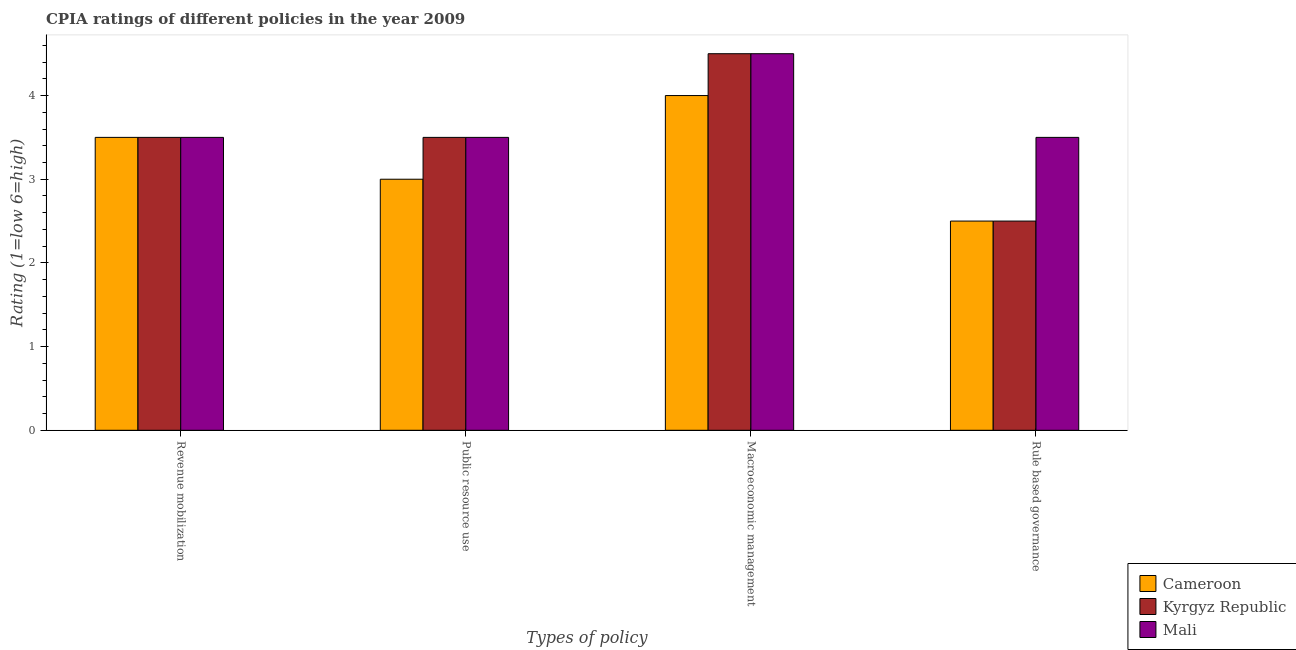How many different coloured bars are there?
Ensure brevity in your answer.  3. How many groups of bars are there?
Provide a short and direct response. 4. Are the number of bars on each tick of the X-axis equal?
Your answer should be compact. Yes. How many bars are there on the 4th tick from the right?
Ensure brevity in your answer.  3. What is the label of the 1st group of bars from the left?
Offer a very short reply. Revenue mobilization. Across all countries, what is the maximum cpia rating of public resource use?
Make the answer very short. 3.5. In which country was the cpia rating of revenue mobilization maximum?
Give a very brief answer. Cameroon. In which country was the cpia rating of revenue mobilization minimum?
Provide a short and direct response. Cameroon. What is the average cpia rating of macroeconomic management per country?
Offer a terse response. 4.33. In how many countries, is the cpia rating of public resource use greater than 3 ?
Keep it short and to the point. 2. What is the ratio of the cpia rating of public resource use in Mali to that in Kyrgyz Republic?
Make the answer very short. 1. What is the difference between the highest and the second highest cpia rating of revenue mobilization?
Your answer should be very brief. 0. What does the 1st bar from the left in Public resource use represents?
Keep it short and to the point. Cameroon. What does the 2nd bar from the right in Macroeconomic management represents?
Provide a short and direct response. Kyrgyz Republic. Is it the case that in every country, the sum of the cpia rating of revenue mobilization and cpia rating of public resource use is greater than the cpia rating of macroeconomic management?
Provide a succinct answer. Yes. Are all the bars in the graph horizontal?
Your response must be concise. No. How many countries are there in the graph?
Ensure brevity in your answer.  3. What is the difference between two consecutive major ticks on the Y-axis?
Provide a succinct answer. 1. Does the graph contain any zero values?
Offer a terse response. No. Does the graph contain grids?
Your response must be concise. No. Where does the legend appear in the graph?
Give a very brief answer. Bottom right. What is the title of the graph?
Your response must be concise. CPIA ratings of different policies in the year 2009. What is the label or title of the X-axis?
Provide a succinct answer. Types of policy. What is the Rating (1=low 6=high) in Cameroon in Revenue mobilization?
Provide a succinct answer. 3.5. What is the Rating (1=low 6=high) in Kyrgyz Republic in Revenue mobilization?
Your response must be concise. 3.5. What is the Rating (1=low 6=high) of Mali in Revenue mobilization?
Keep it short and to the point. 3.5. What is the Rating (1=low 6=high) of Cameroon in Public resource use?
Offer a very short reply. 3. What is the Rating (1=low 6=high) of Kyrgyz Republic in Public resource use?
Offer a very short reply. 3.5. What is the Rating (1=low 6=high) in Cameroon in Macroeconomic management?
Make the answer very short. 4. What is the Rating (1=low 6=high) in Kyrgyz Republic in Rule based governance?
Your answer should be compact. 2.5. What is the Rating (1=low 6=high) of Mali in Rule based governance?
Keep it short and to the point. 3.5. Across all Types of policy, what is the maximum Rating (1=low 6=high) in Cameroon?
Keep it short and to the point. 4. Across all Types of policy, what is the maximum Rating (1=low 6=high) in Kyrgyz Republic?
Provide a succinct answer. 4.5. Across all Types of policy, what is the minimum Rating (1=low 6=high) in Kyrgyz Republic?
Your response must be concise. 2.5. Across all Types of policy, what is the minimum Rating (1=low 6=high) in Mali?
Make the answer very short. 3.5. What is the total Rating (1=low 6=high) in Kyrgyz Republic in the graph?
Give a very brief answer. 14. What is the difference between the Rating (1=low 6=high) in Kyrgyz Republic in Revenue mobilization and that in Public resource use?
Keep it short and to the point. 0. What is the difference between the Rating (1=low 6=high) in Kyrgyz Republic in Revenue mobilization and that in Macroeconomic management?
Offer a very short reply. -1. What is the difference between the Rating (1=low 6=high) in Cameroon in Public resource use and that in Macroeconomic management?
Your answer should be compact. -1. What is the difference between the Rating (1=low 6=high) in Kyrgyz Republic in Public resource use and that in Macroeconomic management?
Offer a very short reply. -1. What is the difference between the Rating (1=low 6=high) of Mali in Public resource use and that in Macroeconomic management?
Your answer should be compact. -1. What is the difference between the Rating (1=low 6=high) in Cameroon in Public resource use and that in Rule based governance?
Provide a succinct answer. 0.5. What is the difference between the Rating (1=low 6=high) of Kyrgyz Republic in Public resource use and that in Rule based governance?
Provide a short and direct response. 1. What is the difference between the Rating (1=low 6=high) in Mali in Public resource use and that in Rule based governance?
Keep it short and to the point. 0. What is the difference between the Rating (1=low 6=high) of Kyrgyz Republic in Macroeconomic management and that in Rule based governance?
Provide a short and direct response. 2. What is the difference between the Rating (1=low 6=high) of Mali in Macroeconomic management and that in Rule based governance?
Give a very brief answer. 1. What is the difference between the Rating (1=low 6=high) in Cameroon in Revenue mobilization and the Rating (1=low 6=high) in Kyrgyz Republic in Public resource use?
Offer a terse response. 0. What is the difference between the Rating (1=low 6=high) in Cameroon in Revenue mobilization and the Rating (1=low 6=high) in Mali in Public resource use?
Offer a terse response. 0. What is the difference between the Rating (1=low 6=high) in Cameroon in Revenue mobilization and the Rating (1=low 6=high) in Mali in Macroeconomic management?
Provide a succinct answer. -1. What is the difference between the Rating (1=low 6=high) in Kyrgyz Republic in Revenue mobilization and the Rating (1=low 6=high) in Mali in Macroeconomic management?
Ensure brevity in your answer.  -1. What is the difference between the Rating (1=low 6=high) of Cameroon in Revenue mobilization and the Rating (1=low 6=high) of Kyrgyz Republic in Rule based governance?
Keep it short and to the point. 1. What is the difference between the Rating (1=low 6=high) of Kyrgyz Republic in Revenue mobilization and the Rating (1=low 6=high) of Mali in Rule based governance?
Your answer should be very brief. 0. What is the difference between the Rating (1=low 6=high) of Cameroon in Public resource use and the Rating (1=low 6=high) of Mali in Macroeconomic management?
Make the answer very short. -1.5. What is the difference between the Rating (1=low 6=high) of Cameroon in Macroeconomic management and the Rating (1=low 6=high) of Kyrgyz Republic in Rule based governance?
Keep it short and to the point. 1.5. What is the average Rating (1=low 6=high) in Cameroon per Types of policy?
Make the answer very short. 3.25. What is the average Rating (1=low 6=high) in Mali per Types of policy?
Give a very brief answer. 3.75. What is the difference between the Rating (1=low 6=high) in Cameroon and Rating (1=low 6=high) in Mali in Revenue mobilization?
Give a very brief answer. 0. What is the difference between the Rating (1=low 6=high) in Kyrgyz Republic and Rating (1=low 6=high) in Mali in Revenue mobilization?
Your answer should be compact. 0. What is the difference between the Rating (1=low 6=high) of Cameroon and Rating (1=low 6=high) of Kyrgyz Republic in Public resource use?
Ensure brevity in your answer.  -0.5. What is the difference between the Rating (1=low 6=high) in Cameroon and Rating (1=low 6=high) in Kyrgyz Republic in Macroeconomic management?
Make the answer very short. -0.5. What is the difference between the Rating (1=low 6=high) in Cameroon and Rating (1=low 6=high) in Mali in Macroeconomic management?
Make the answer very short. -0.5. What is the difference between the Rating (1=low 6=high) of Kyrgyz Republic and Rating (1=low 6=high) of Mali in Macroeconomic management?
Ensure brevity in your answer.  0. What is the difference between the Rating (1=low 6=high) of Cameroon and Rating (1=low 6=high) of Kyrgyz Republic in Rule based governance?
Keep it short and to the point. 0. What is the ratio of the Rating (1=low 6=high) of Cameroon in Revenue mobilization to that in Macroeconomic management?
Offer a very short reply. 0.88. What is the ratio of the Rating (1=low 6=high) of Mali in Revenue mobilization to that in Macroeconomic management?
Offer a very short reply. 0.78. What is the ratio of the Rating (1=low 6=high) of Kyrgyz Republic in Revenue mobilization to that in Rule based governance?
Your answer should be very brief. 1.4. What is the ratio of the Rating (1=low 6=high) in Mali in Revenue mobilization to that in Rule based governance?
Provide a short and direct response. 1. What is the ratio of the Rating (1=low 6=high) of Cameroon in Macroeconomic management to that in Rule based governance?
Offer a terse response. 1.6. What is the difference between the highest and the second highest Rating (1=low 6=high) of Cameroon?
Make the answer very short. 0.5. What is the difference between the highest and the second highest Rating (1=low 6=high) of Kyrgyz Republic?
Offer a very short reply. 1. 